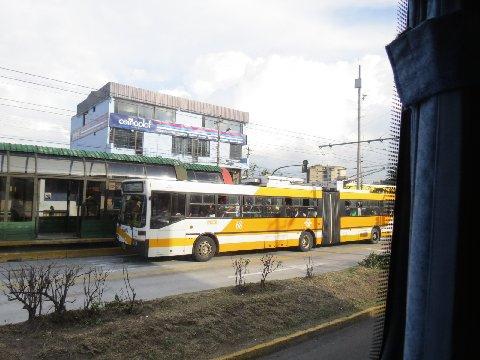The color of the bus is white and what?
Give a very brief answer. Yellow. What is the weather like?
Be succinct. Cloudy. Is this a regular sized bus?
Quick response, please. No. 